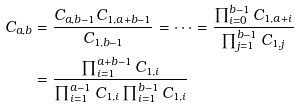Convert formula to latex. <formula><loc_0><loc_0><loc_500><loc_500>C _ { a , b } & = \frac { C _ { a , b - 1 } C _ { 1 , a + b - 1 } } { C _ { 1 , b - 1 } } = \cdots = \frac { \prod _ { i = 0 } ^ { b - 1 } C _ { 1 , a + i } } { \prod _ { j = 1 } ^ { b - 1 } C _ { 1 , j } } \\ & = \frac { \prod _ { i = 1 } ^ { a + b - 1 } C _ { 1 , i } } { \prod _ { i = 1 } ^ { a - 1 } C _ { 1 , i } \prod _ { i = 1 } ^ { b - 1 } C _ { 1 , i } }</formula> 